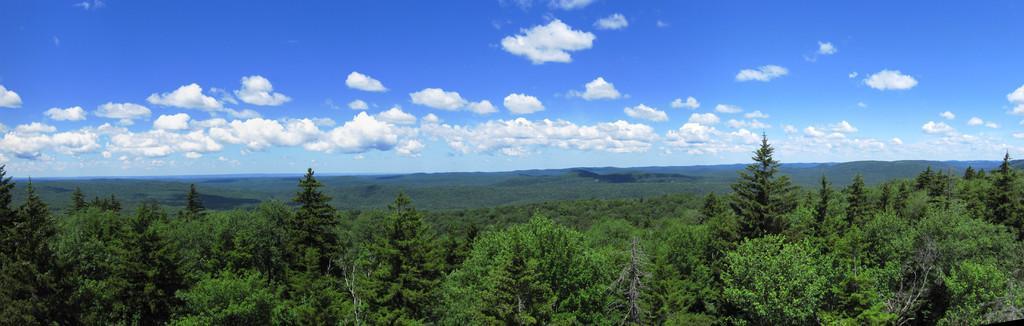Can you describe this image briefly? In this image there is the sky towards the top of the image, there are clouds in the sky, there are trees towards the bottom of the image. 